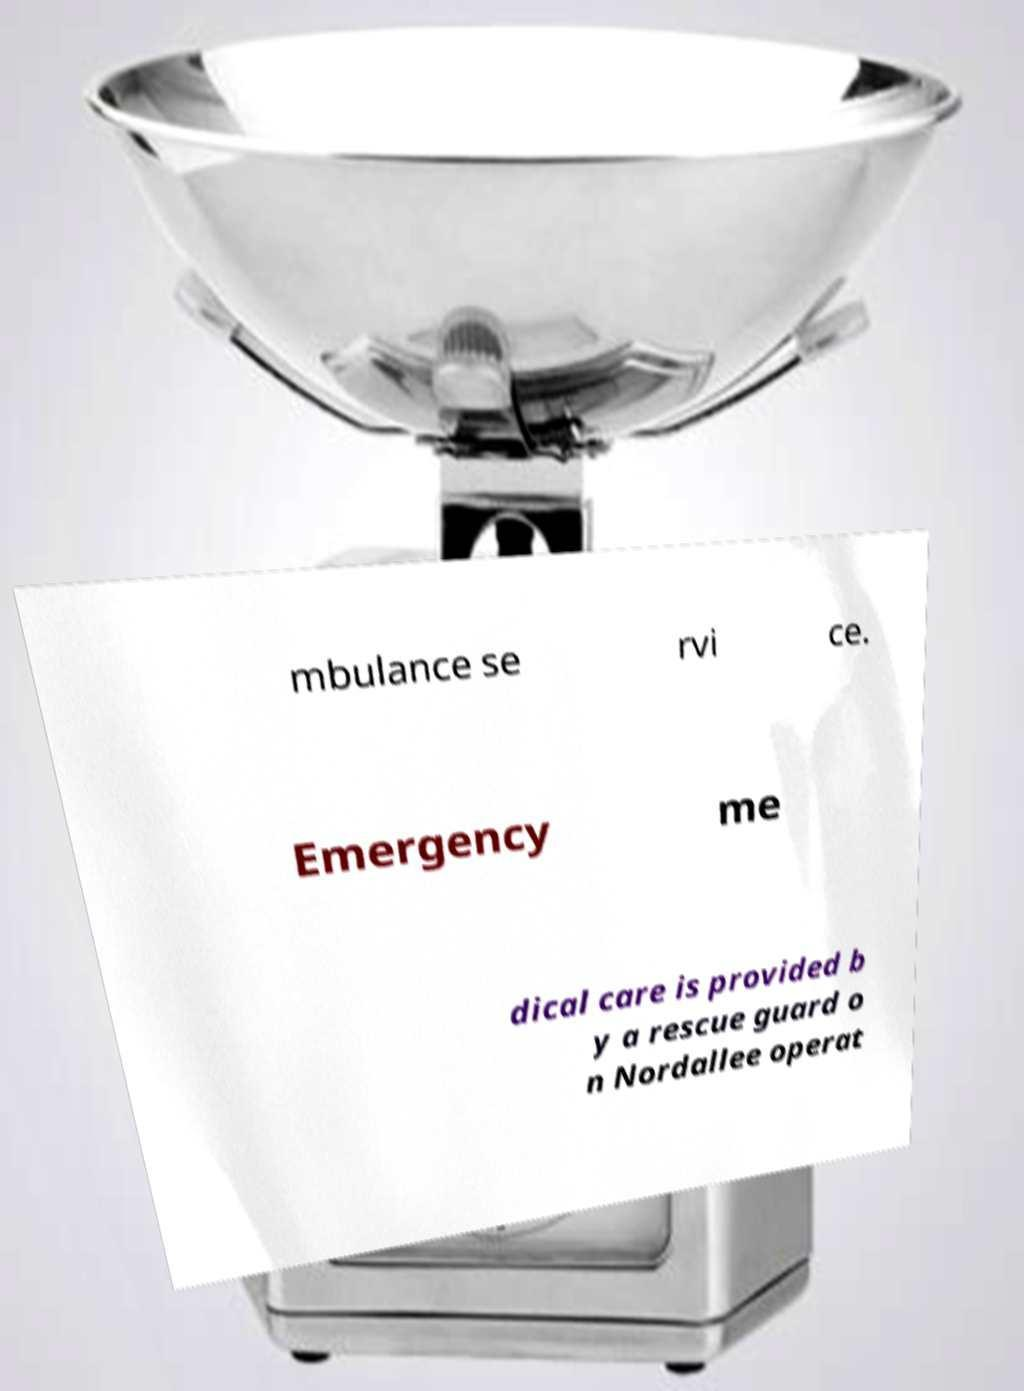What messages or text are displayed in this image? I need them in a readable, typed format. mbulance se rvi ce. Emergency me dical care is provided b y a rescue guard o n Nordallee operat 